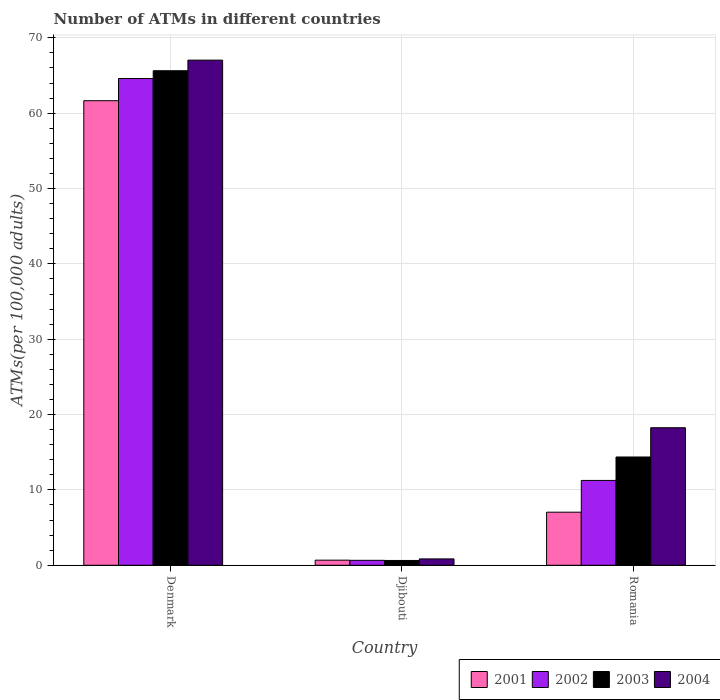How many different coloured bars are there?
Offer a terse response. 4. Are the number of bars per tick equal to the number of legend labels?
Keep it short and to the point. Yes. Are the number of bars on each tick of the X-axis equal?
Provide a short and direct response. Yes. What is the label of the 2nd group of bars from the left?
Offer a very short reply. Djibouti. In how many cases, is the number of bars for a given country not equal to the number of legend labels?
Ensure brevity in your answer.  0. What is the number of ATMs in 2004 in Djibouti?
Provide a short and direct response. 0.84. Across all countries, what is the maximum number of ATMs in 2002?
Provide a short and direct response. 64.61. Across all countries, what is the minimum number of ATMs in 2001?
Keep it short and to the point. 0.68. In which country was the number of ATMs in 2001 maximum?
Offer a terse response. Denmark. In which country was the number of ATMs in 2001 minimum?
Offer a very short reply. Djibouti. What is the total number of ATMs in 2003 in the graph?
Offer a very short reply. 80.65. What is the difference between the number of ATMs in 2001 in Djibouti and that in Romania?
Offer a terse response. -6.37. What is the difference between the number of ATMs in 2004 in Denmark and the number of ATMs in 2002 in Romania?
Make the answer very short. 55.78. What is the average number of ATMs in 2003 per country?
Offer a terse response. 26.88. What is the difference between the number of ATMs of/in 2003 and number of ATMs of/in 2001 in Romania?
Keep it short and to the point. 7.32. In how many countries, is the number of ATMs in 2002 greater than 44?
Your answer should be very brief. 1. What is the ratio of the number of ATMs in 2001 in Denmark to that in Djibouti?
Your answer should be compact. 91.18. Is the number of ATMs in 2002 in Djibouti less than that in Romania?
Your response must be concise. Yes. What is the difference between the highest and the second highest number of ATMs in 2002?
Ensure brevity in your answer.  63.95. What is the difference between the highest and the lowest number of ATMs in 2001?
Your response must be concise. 60.98. In how many countries, is the number of ATMs in 2003 greater than the average number of ATMs in 2003 taken over all countries?
Offer a terse response. 1. What does the 1st bar from the right in Denmark represents?
Make the answer very short. 2004. How many bars are there?
Keep it short and to the point. 12. Are all the bars in the graph horizontal?
Make the answer very short. No. How many countries are there in the graph?
Keep it short and to the point. 3. What is the difference between two consecutive major ticks on the Y-axis?
Your answer should be compact. 10. Where does the legend appear in the graph?
Keep it short and to the point. Bottom right. How many legend labels are there?
Make the answer very short. 4. How are the legend labels stacked?
Keep it short and to the point. Horizontal. What is the title of the graph?
Give a very brief answer. Number of ATMs in different countries. Does "2005" appear as one of the legend labels in the graph?
Offer a terse response. No. What is the label or title of the Y-axis?
Make the answer very short. ATMs(per 100,0 adults). What is the ATMs(per 100,000 adults) in 2001 in Denmark?
Offer a terse response. 61.66. What is the ATMs(per 100,000 adults) of 2002 in Denmark?
Give a very brief answer. 64.61. What is the ATMs(per 100,000 adults) of 2003 in Denmark?
Your answer should be compact. 65.64. What is the ATMs(per 100,000 adults) in 2004 in Denmark?
Provide a succinct answer. 67.04. What is the ATMs(per 100,000 adults) in 2001 in Djibouti?
Your answer should be very brief. 0.68. What is the ATMs(per 100,000 adults) in 2002 in Djibouti?
Provide a short and direct response. 0.66. What is the ATMs(per 100,000 adults) in 2003 in Djibouti?
Give a very brief answer. 0.64. What is the ATMs(per 100,000 adults) in 2004 in Djibouti?
Offer a very short reply. 0.84. What is the ATMs(per 100,000 adults) in 2001 in Romania?
Make the answer very short. 7.04. What is the ATMs(per 100,000 adults) of 2002 in Romania?
Your answer should be very brief. 11.26. What is the ATMs(per 100,000 adults) of 2003 in Romania?
Keep it short and to the point. 14.37. What is the ATMs(per 100,000 adults) of 2004 in Romania?
Your answer should be very brief. 18.26. Across all countries, what is the maximum ATMs(per 100,000 adults) in 2001?
Ensure brevity in your answer.  61.66. Across all countries, what is the maximum ATMs(per 100,000 adults) of 2002?
Your answer should be very brief. 64.61. Across all countries, what is the maximum ATMs(per 100,000 adults) of 2003?
Offer a very short reply. 65.64. Across all countries, what is the maximum ATMs(per 100,000 adults) of 2004?
Your answer should be compact. 67.04. Across all countries, what is the minimum ATMs(per 100,000 adults) in 2001?
Make the answer very short. 0.68. Across all countries, what is the minimum ATMs(per 100,000 adults) of 2002?
Keep it short and to the point. 0.66. Across all countries, what is the minimum ATMs(per 100,000 adults) in 2003?
Make the answer very short. 0.64. Across all countries, what is the minimum ATMs(per 100,000 adults) in 2004?
Offer a very short reply. 0.84. What is the total ATMs(per 100,000 adults) in 2001 in the graph?
Give a very brief answer. 69.38. What is the total ATMs(per 100,000 adults) of 2002 in the graph?
Your response must be concise. 76.52. What is the total ATMs(per 100,000 adults) in 2003 in the graph?
Offer a very short reply. 80.65. What is the total ATMs(per 100,000 adults) in 2004 in the graph?
Your response must be concise. 86.14. What is the difference between the ATMs(per 100,000 adults) of 2001 in Denmark and that in Djibouti?
Provide a succinct answer. 60.98. What is the difference between the ATMs(per 100,000 adults) of 2002 in Denmark and that in Djibouti?
Offer a terse response. 63.95. What is the difference between the ATMs(per 100,000 adults) in 2003 in Denmark and that in Djibouti?
Ensure brevity in your answer.  65. What is the difference between the ATMs(per 100,000 adults) of 2004 in Denmark and that in Djibouti?
Offer a very short reply. 66.2. What is the difference between the ATMs(per 100,000 adults) of 2001 in Denmark and that in Romania?
Offer a very short reply. 54.61. What is the difference between the ATMs(per 100,000 adults) of 2002 in Denmark and that in Romania?
Keep it short and to the point. 53.35. What is the difference between the ATMs(per 100,000 adults) of 2003 in Denmark and that in Romania?
Offer a very short reply. 51.27. What is the difference between the ATMs(per 100,000 adults) in 2004 in Denmark and that in Romania?
Provide a short and direct response. 48.79. What is the difference between the ATMs(per 100,000 adults) of 2001 in Djibouti and that in Romania?
Provide a succinct answer. -6.37. What is the difference between the ATMs(per 100,000 adults) of 2002 in Djibouti and that in Romania?
Your answer should be very brief. -10.6. What is the difference between the ATMs(per 100,000 adults) in 2003 in Djibouti and that in Romania?
Provide a succinct answer. -13.73. What is the difference between the ATMs(per 100,000 adults) in 2004 in Djibouti and that in Romania?
Keep it short and to the point. -17.41. What is the difference between the ATMs(per 100,000 adults) in 2001 in Denmark and the ATMs(per 100,000 adults) in 2002 in Djibouti?
Your response must be concise. 61. What is the difference between the ATMs(per 100,000 adults) in 2001 in Denmark and the ATMs(per 100,000 adults) in 2003 in Djibouti?
Offer a terse response. 61.02. What is the difference between the ATMs(per 100,000 adults) of 2001 in Denmark and the ATMs(per 100,000 adults) of 2004 in Djibouti?
Provide a succinct answer. 60.81. What is the difference between the ATMs(per 100,000 adults) of 2002 in Denmark and the ATMs(per 100,000 adults) of 2003 in Djibouti?
Make the answer very short. 63.97. What is the difference between the ATMs(per 100,000 adults) of 2002 in Denmark and the ATMs(per 100,000 adults) of 2004 in Djibouti?
Offer a terse response. 63.76. What is the difference between the ATMs(per 100,000 adults) of 2003 in Denmark and the ATMs(per 100,000 adults) of 2004 in Djibouti?
Offer a very short reply. 64.79. What is the difference between the ATMs(per 100,000 adults) in 2001 in Denmark and the ATMs(per 100,000 adults) in 2002 in Romania?
Ensure brevity in your answer.  50.4. What is the difference between the ATMs(per 100,000 adults) of 2001 in Denmark and the ATMs(per 100,000 adults) of 2003 in Romania?
Provide a succinct answer. 47.29. What is the difference between the ATMs(per 100,000 adults) in 2001 in Denmark and the ATMs(per 100,000 adults) in 2004 in Romania?
Provide a succinct answer. 43.4. What is the difference between the ATMs(per 100,000 adults) of 2002 in Denmark and the ATMs(per 100,000 adults) of 2003 in Romania?
Your answer should be very brief. 50.24. What is the difference between the ATMs(per 100,000 adults) in 2002 in Denmark and the ATMs(per 100,000 adults) in 2004 in Romania?
Your answer should be compact. 46.35. What is the difference between the ATMs(per 100,000 adults) of 2003 in Denmark and the ATMs(per 100,000 adults) of 2004 in Romania?
Keep it short and to the point. 47.38. What is the difference between the ATMs(per 100,000 adults) of 2001 in Djibouti and the ATMs(per 100,000 adults) of 2002 in Romania?
Offer a terse response. -10.58. What is the difference between the ATMs(per 100,000 adults) in 2001 in Djibouti and the ATMs(per 100,000 adults) in 2003 in Romania?
Offer a very short reply. -13.69. What is the difference between the ATMs(per 100,000 adults) of 2001 in Djibouti and the ATMs(per 100,000 adults) of 2004 in Romania?
Offer a terse response. -17.58. What is the difference between the ATMs(per 100,000 adults) in 2002 in Djibouti and the ATMs(per 100,000 adults) in 2003 in Romania?
Give a very brief answer. -13.71. What is the difference between the ATMs(per 100,000 adults) of 2002 in Djibouti and the ATMs(per 100,000 adults) of 2004 in Romania?
Keep it short and to the point. -17.6. What is the difference between the ATMs(per 100,000 adults) of 2003 in Djibouti and the ATMs(per 100,000 adults) of 2004 in Romania?
Offer a very short reply. -17.62. What is the average ATMs(per 100,000 adults) of 2001 per country?
Offer a terse response. 23.13. What is the average ATMs(per 100,000 adults) in 2002 per country?
Provide a succinct answer. 25.51. What is the average ATMs(per 100,000 adults) in 2003 per country?
Keep it short and to the point. 26.88. What is the average ATMs(per 100,000 adults) of 2004 per country?
Your response must be concise. 28.71. What is the difference between the ATMs(per 100,000 adults) in 2001 and ATMs(per 100,000 adults) in 2002 in Denmark?
Give a very brief answer. -2.95. What is the difference between the ATMs(per 100,000 adults) of 2001 and ATMs(per 100,000 adults) of 2003 in Denmark?
Your answer should be compact. -3.98. What is the difference between the ATMs(per 100,000 adults) of 2001 and ATMs(per 100,000 adults) of 2004 in Denmark?
Offer a very short reply. -5.39. What is the difference between the ATMs(per 100,000 adults) of 2002 and ATMs(per 100,000 adults) of 2003 in Denmark?
Provide a succinct answer. -1.03. What is the difference between the ATMs(per 100,000 adults) of 2002 and ATMs(per 100,000 adults) of 2004 in Denmark?
Provide a short and direct response. -2.44. What is the difference between the ATMs(per 100,000 adults) of 2003 and ATMs(per 100,000 adults) of 2004 in Denmark?
Make the answer very short. -1.41. What is the difference between the ATMs(per 100,000 adults) in 2001 and ATMs(per 100,000 adults) in 2002 in Djibouti?
Offer a terse response. 0.02. What is the difference between the ATMs(per 100,000 adults) in 2001 and ATMs(per 100,000 adults) in 2003 in Djibouti?
Ensure brevity in your answer.  0.04. What is the difference between the ATMs(per 100,000 adults) of 2001 and ATMs(per 100,000 adults) of 2004 in Djibouti?
Ensure brevity in your answer.  -0.17. What is the difference between the ATMs(per 100,000 adults) in 2002 and ATMs(per 100,000 adults) in 2003 in Djibouti?
Keep it short and to the point. 0.02. What is the difference between the ATMs(per 100,000 adults) in 2002 and ATMs(per 100,000 adults) in 2004 in Djibouti?
Provide a short and direct response. -0.19. What is the difference between the ATMs(per 100,000 adults) of 2003 and ATMs(per 100,000 adults) of 2004 in Djibouti?
Offer a very short reply. -0.21. What is the difference between the ATMs(per 100,000 adults) of 2001 and ATMs(per 100,000 adults) of 2002 in Romania?
Offer a very short reply. -4.21. What is the difference between the ATMs(per 100,000 adults) in 2001 and ATMs(per 100,000 adults) in 2003 in Romania?
Make the answer very short. -7.32. What is the difference between the ATMs(per 100,000 adults) in 2001 and ATMs(per 100,000 adults) in 2004 in Romania?
Your answer should be very brief. -11.21. What is the difference between the ATMs(per 100,000 adults) of 2002 and ATMs(per 100,000 adults) of 2003 in Romania?
Make the answer very short. -3.11. What is the difference between the ATMs(per 100,000 adults) of 2002 and ATMs(per 100,000 adults) of 2004 in Romania?
Provide a short and direct response. -7. What is the difference between the ATMs(per 100,000 adults) in 2003 and ATMs(per 100,000 adults) in 2004 in Romania?
Your response must be concise. -3.89. What is the ratio of the ATMs(per 100,000 adults) in 2001 in Denmark to that in Djibouti?
Provide a succinct answer. 91.18. What is the ratio of the ATMs(per 100,000 adults) of 2002 in Denmark to that in Djibouti?
Your response must be concise. 98.45. What is the ratio of the ATMs(per 100,000 adults) of 2003 in Denmark to that in Djibouti?
Your response must be concise. 102.88. What is the ratio of the ATMs(per 100,000 adults) in 2004 in Denmark to that in Djibouti?
Provide a short and direct response. 79.46. What is the ratio of the ATMs(per 100,000 adults) of 2001 in Denmark to that in Romania?
Provide a short and direct response. 8.75. What is the ratio of the ATMs(per 100,000 adults) of 2002 in Denmark to that in Romania?
Provide a short and direct response. 5.74. What is the ratio of the ATMs(per 100,000 adults) in 2003 in Denmark to that in Romania?
Make the answer very short. 4.57. What is the ratio of the ATMs(per 100,000 adults) in 2004 in Denmark to that in Romania?
Provide a short and direct response. 3.67. What is the ratio of the ATMs(per 100,000 adults) in 2001 in Djibouti to that in Romania?
Give a very brief answer. 0.1. What is the ratio of the ATMs(per 100,000 adults) in 2002 in Djibouti to that in Romania?
Your answer should be compact. 0.06. What is the ratio of the ATMs(per 100,000 adults) in 2003 in Djibouti to that in Romania?
Keep it short and to the point. 0.04. What is the ratio of the ATMs(per 100,000 adults) of 2004 in Djibouti to that in Romania?
Give a very brief answer. 0.05. What is the difference between the highest and the second highest ATMs(per 100,000 adults) of 2001?
Give a very brief answer. 54.61. What is the difference between the highest and the second highest ATMs(per 100,000 adults) of 2002?
Make the answer very short. 53.35. What is the difference between the highest and the second highest ATMs(per 100,000 adults) in 2003?
Provide a succinct answer. 51.27. What is the difference between the highest and the second highest ATMs(per 100,000 adults) of 2004?
Offer a very short reply. 48.79. What is the difference between the highest and the lowest ATMs(per 100,000 adults) in 2001?
Offer a very short reply. 60.98. What is the difference between the highest and the lowest ATMs(per 100,000 adults) of 2002?
Make the answer very short. 63.95. What is the difference between the highest and the lowest ATMs(per 100,000 adults) in 2003?
Keep it short and to the point. 65. What is the difference between the highest and the lowest ATMs(per 100,000 adults) in 2004?
Your response must be concise. 66.2. 